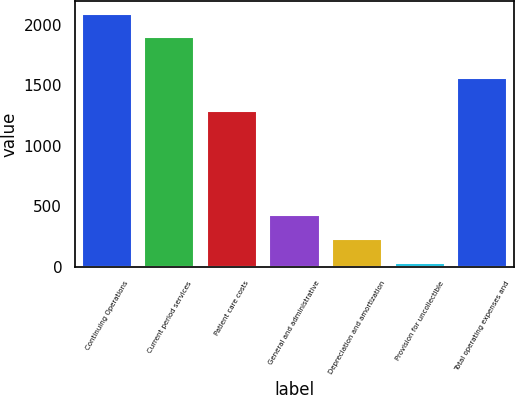Convert chart. <chart><loc_0><loc_0><loc_500><loc_500><bar_chart><fcel>Continuing Operations<fcel>Current period services<fcel>Patient care costs<fcel>General and administrative<fcel>Depreciation and amortization<fcel>Provision for uncollectible<fcel>Total operating expenses and<nl><fcel>2091.9<fcel>1895<fcel>1288<fcel>427.8<fcel>230.9<fcel>34<fcel>1560<nl></chart> 